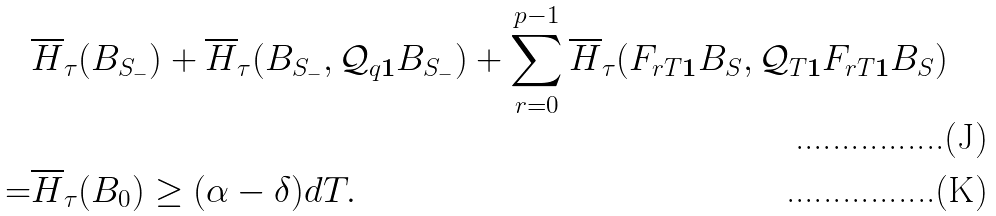<formula> <loc_0><loc_0><loc_500><loc_500>& \overline { H } _ { \tau } ( B _ { S _ { - } } ) + \overline { H } _ { \tau } ( B _ { S _ { - } } , \mathcal { Q } _ { q \mathbf 1 } B _ { S _ { - } } ) + \sum _ { r = 0 } ^ { p - 1 } \overline { H } _ { \tau } ( F _ { r T \mathbf 1 } B _ { S } , \mathcal { Q } _ { T \mathbf 1 } F _ { r T \mathbf 1 } B _ { S } ) \\ = & \overline { H } _ { \tau } ( B _ { 0 } ) \geq ( \alpha - \delta ) d T .</formula> 